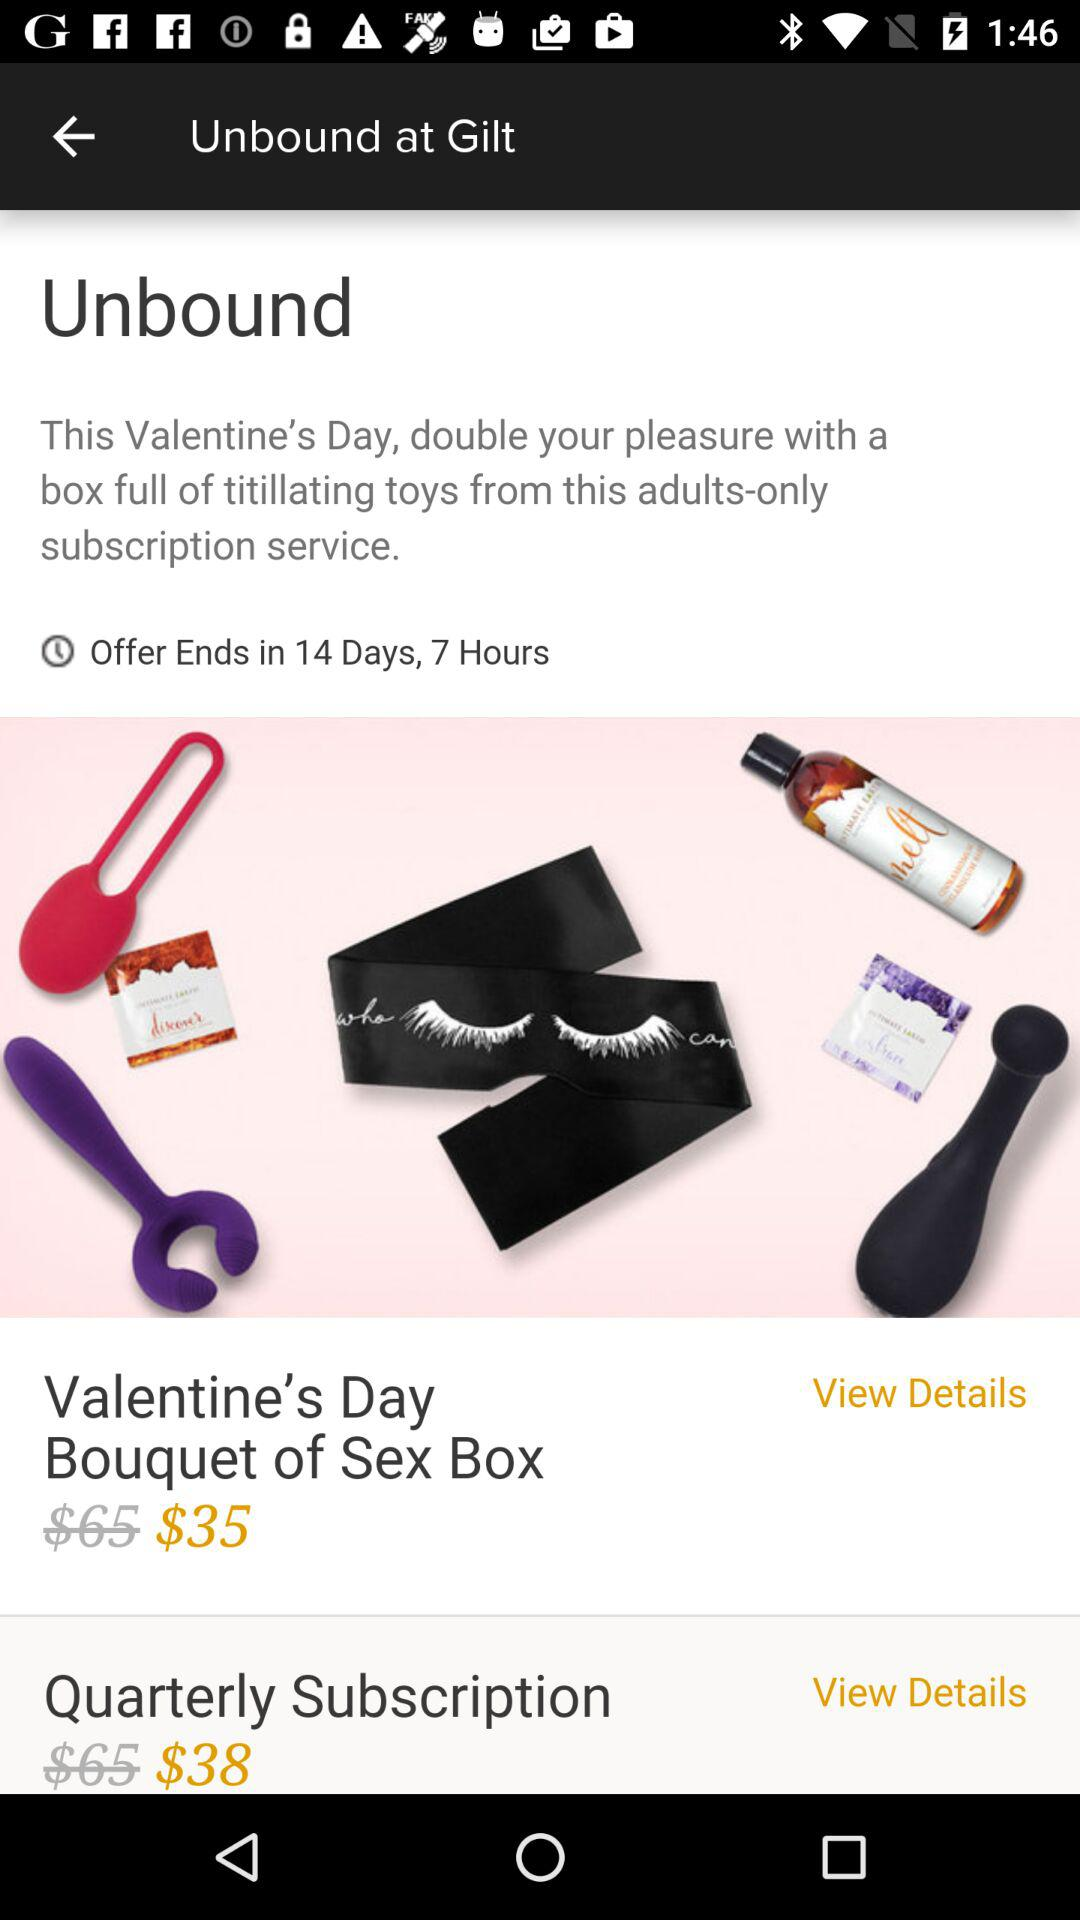What's the original cost of the Valentine's Day bouquet sex box? The original cost is $65. 